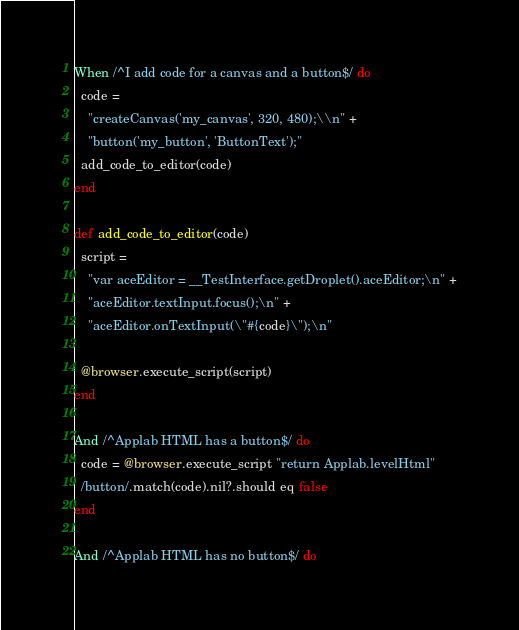Convert code to text. <code><loc_0><loc_0><loc_500><loc_500><_Ruby_>When /^I add code for a canvas and a button$/ do
  code =
    "createCanvas('my_canvas', 320, 480);\\n" +
    "button('my_button', 'ButtonText');"
  add_code_to_editor(code)
end

def add_code_to_editor(code)
  script =
    "var aceEditor = __TestInterface.getDroplet().aceEditor;\n" +
    "aceEditor.textInput.focus();\n" +
    "aceEditor.onTextInput(\"#{code}\");\n"

  @browser.execute_script(script)
end

And /^Applab HTML has a button$/ do
  code = @browser.execute_script "return Applab.levelHtml"
  /button/.match(code).nil?.should eq false
end

And /^Applab HTML has no button$/ do</code> 